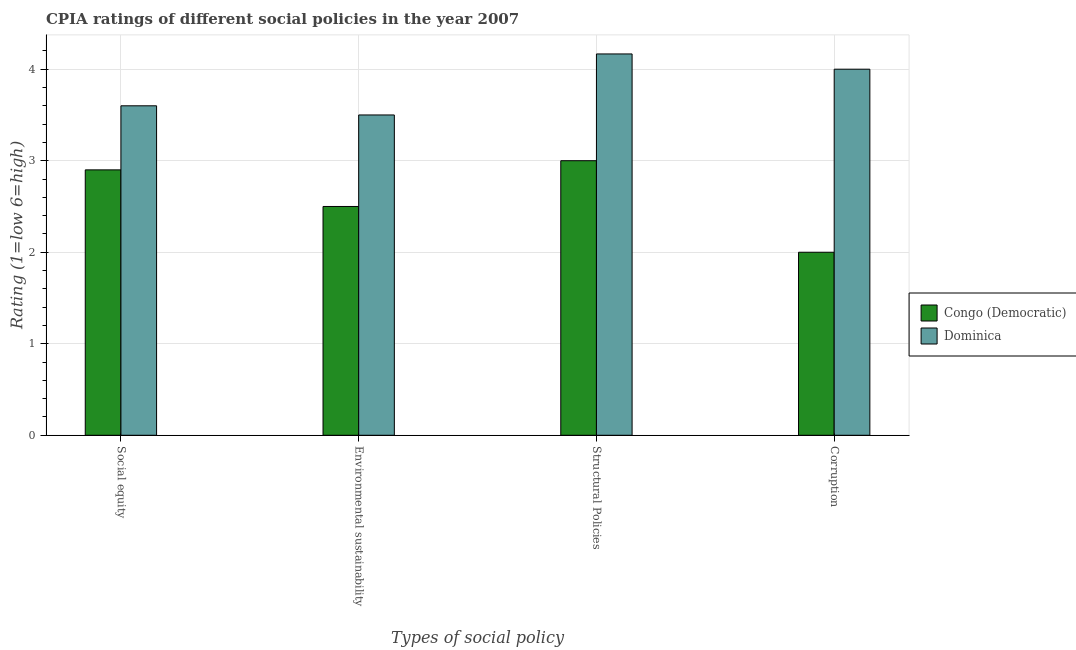How many different coloured bars are there?
Make the answer very short. 2. How many groups of bars are there?
Your answer should be compact. 4. Are the number of bars per tick equal to the number of legend labels?
Keep it short and to the point. Yes. Are the number of bars on each tick of the X-axis equal?
Make the answer very short. Yes. How many bars are there on the 1st tick from the left?
Make the answer very short. 2. How many bars are there on the 4th tick from the right?
Your answer should be compact. 2. What is the label of the 2nd group of bars from the left?
Your answer should be compact. Environmental sustainability. Across all countries, what is the minimum cpia rating of environmental sustainability?
Your answer should be very brief. 2.5. In which country was the cpia rating of environmental sustainability maximum?
Keep it short and to the point. Dominica. In which country was the cpia rating of social equity minimum?
Provide a succinct answer. Congo (Democratic). What is the total cpia rating of social equity in the graph?
Give a very brief answer. 6.5. What is the difference between the cpia rating of structural policies in Dominica and the cpia rating of corruption in Congo (Democratic)?
Offer a terse response. 2.17. What is the average cpia rating of structural policies per country?
Keep it short and to the point. 3.58. What is the difference between the cpia rating of corruption and cpia rating of environmental sustainability in Dominica?
Your response must be concise. 0.5. What is the ratio of the cpia rating of environmental sustainability in Dominica to that in Congo (Democratic)?
Keep it short and to the point. 1.4. What is the difference between the highest and the second highest cpia rating of environmental sustainability?
Make the answer very short. 1. Is it the case that in every country, the sum of the cpia rating of structural policies and cpia rating of environmental sustainability is greater than the sum of cpia rating of social equity and cpia rating of corruption?
Give a very brief answer. No. What does the 1st bar from the left in Corruption represents?
Offer a terse response. Congo (Democratic). What does the 1st bar from the right in Social equity represents?
Your answer should be very brief. Dominica. Are all the bars in the graph horizontal?
Your answer should be compact. No. What is the difference between two consecutive major ticks on the Y-axis?
Make the answer very short. 1. Are the values on the major ticks of Y-axis written in scientific E-notation?
Provide a short and direct response. No. Does the graph contain grids?
Your answer should be very brief. Yes. How many legend labels are there?
Your response must be concise. 2. What is the title of the graph?
Your answer should be very brief. CPIA ratings of different social policies in the year 2007. Does "Middle income" appear as one of the legend labels in the graph?
Make the answer very short. No. What is the label or title of the X-axis?
Provide a short and direct response. Types of social policy. What is the Rating (1=low 6=high) of Congo (Democratic) in Social equity?
Provide a short and direct response. 2.9. What is the Rating (1=low 6=high) in Dominica in Environmental sustainability?
Offer a very short reply. 3.5. What is the Rating (1=low 6=high) of Dominica in Structural Policies?
Offer a terse response. 4.17. Across all Types of social policy, what is the maximum Rating (1=low 6=high) in Congo (Democratic)?
Provide a succinct answer. 3. Across all Types of social policy, what is the maximum Rating (1=low 6=high) of Dominica?
Ensure brevity in your answer.  4.17. Across all Types of social policy, what is the minimum Rating (1=low 6=high) of Congo (Democratic)?
Give a very brief answer. 2. Across all Types of social policy, what is the minimum Rating (1=low 6=high) of Dominica?
Ensure brevity in your answer.  3.5. What is the total Rating (1=low 6=high) of Congo (Democratic) in the graph?
Your response must be concise. 10.4. What is the total Rating (1=low 6=high) in Dominica in the graph?
Keep it short and to the point. 15.27. What is the difference between the Rating (1=low 6=high) in Congo (Democratic) in Social equity and that in Structural Policies?
Your response must be concise. -0.1. What is the difference between the Rating (1=low 6=high) in Dominica in Social equity and that in Structural Policies?
Your answer should be very brief. -0.57. What is the difference between the Rating (1=low 6=high) in Dominica in Social equity and that in Corruption?
Your answer should be very brief. -0.4. What is the difference between the Rating (1=low 6=high) in Congo (Democratic) in Environmental sustainability and that in Structural Policies?
Make the answer very short. -0.5. What is the difference between the Rating (1=low 6=high) in Dominica in Environmental sustainability and that in Corruption?
Ensure brevity in your answer.  -0.5. What is the difference between the Rating (1=low 6=high) of Congo (Democratic) in Structural Policies and that in Corruption?
Your answer should be compact. 1. What is the difference between the Rating (1=low 6=high) in Congo (Democratic) in Social equity and the Rating (1=low 6=high) in Dominica in Environmental sustainability?
Offer a terse response. -0.6. What is the difference between the Rating (1=low 6=high) of Congo (Democratic) in Social equity and the Rating (1=low 6=high) of Dominica in Structural Policies?
Your response must be concise. -1.27. What is the difference between the Rating (1=low 6=high) of Congo (Democratic) in Social equity and the Rating (1=low 6=high) of Dominica in Corruption?
Your response must be concise. -1.1. What is the difference between the Rating (1=low 6=high) of Congo (Democratic) in Environmental sustainability and the Rating (1=low 6=high) of Dominica in Structural Policies?
Your answer should be very brief. -1.67. What is the difference between the Rating (1=low 6=high) in Congo (Democratic) in Environmental sustainability and the Rating (1=low 6=high) in Dominica in Corruption?
Offer a terse response. -1.5. What is the difference between the Rating (1=low 6=high) of Congo (Democratic) in Structural Policies and the Rating (1=low 6=high) of Dominica in Corruption?
Your response must be concise. -1. What is the average Rating (1=low 6=high) in Congo (Democratic) per Types of social policy?
Your response must be concise. 2.6. What is the average Rating (1=low 6=high) in Dominica per Types of social policy?
Offer a terse response. 3.82. What is the difference between the Rating (1=low 6=high) of Congo (Democratic) and Rating (1=low 6=high) of Dominica in Social equity?
Provide a succinct answer. -0.7. What is the difference between the Rating (1=low 6=high) of Congo (Democratic) and Rating (1=low 6=high) of Dominica in Environmental sustainability?
Your response must be concise. -1. What is the difference between the Rating (1=low 6=high) of Congo (Democratic) and Rating (1=low 6=high) of Dominica in Structural Policies?
Offer a very short reply. -1.17. What is the ratio of the Rating (1=low 6=high) of Congo (Democratic) in Social equity to that in Environmental sustainability?
Provide a short and direct response. 1.16. What is the ratio of the Rating (1=low 6=high) in Dominica in Social equity to that in Environmental sustainability?
Your response must be concise. 1.03. What is the ratio of the Rating (1=low 6=high) in Congo (Democratic) in Social equity to that in Structural Policies?
Offer a very short reply. 0.97. What is the ratio of the Rating (1=low 6=high) in Dominica in Social equity to that in Structural Policies?
Give a very brief answer. 0.86. What is the ratio of the Rating (1=low 6=high) of Congo (Democratic) in Social equity to that in Corruption?
Keep it short and to the point. 1.45. What is the ratio of the Rating (1=low 6=high) in Dominica in Social equity to that in Corruption?
Ensure brevity in your answer.  0.9. What is the ratio of the Rating (1=low 6=high) in Dominica in Environmental sustainability to that in Structural Policies?
Make the answer very short. 0.84. What is the ratio of the Rating (1=low 6=high) in Congo (Democratic) in Environmental sustainability to that in Corruption?
Ensure brevity in your answer.  1.25. What is the ratio of the Rating (1=low 6=high) of Dominica in Environmental sustainability to that in Corruption?
Ensure brevity in your answer.  0.88. What is the ratio of the Rating (1=low 6=high) in Dominica in Structural Policies to that in Corruption?
Provide a succinct answer. 1.04. What is the difference between the highest and the lowest Rating (1=low 6=high) in Dominica?
Your answer should be very brief. 0.67. 